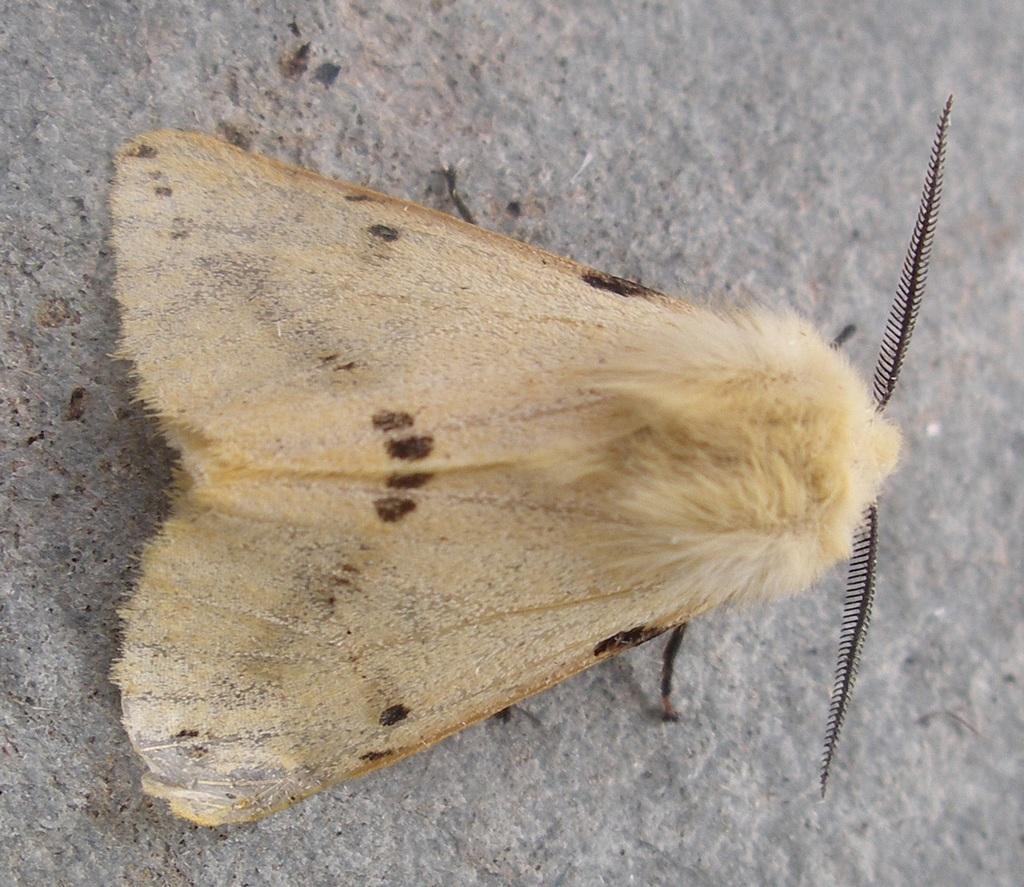Could you give a brief overview of what you see in this image? In this picture there is a moth in the image. 